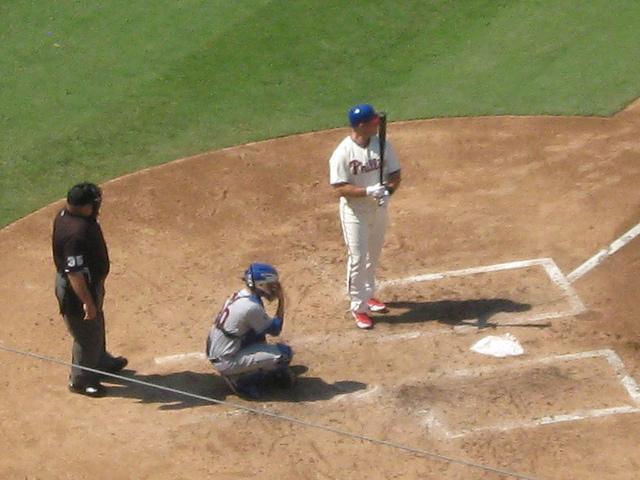How many people are there?
Give a very brief answer. 3. How many horses in this picture do not have white feet?
Give a very brief answer. 0. 